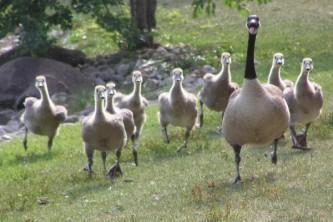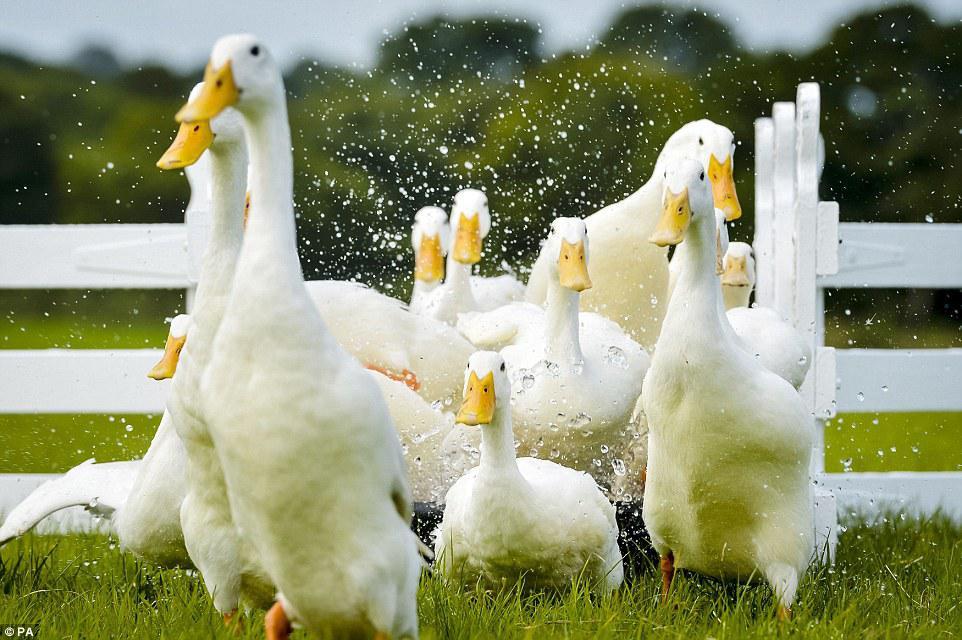The first image is the image on the left, the second image is the image on the right. Considering the images on both sides, is "A flock of all white geese are in at least one image." valid? Answer yes or no. Yes. The first image is the image on the left, the second image is the image on the right. Examine the images to the left and right. Is the description "An image shows at least eight solid-white ducks moving toward the camera." accurate? Answer yes or no. Yes. 